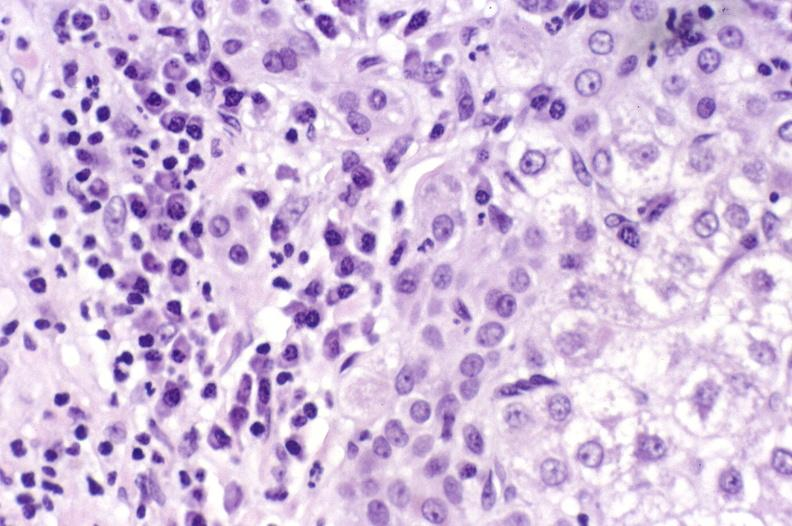what does this image show?
Answer the question using a single word or phrase. Primary biliary cirrhosis 